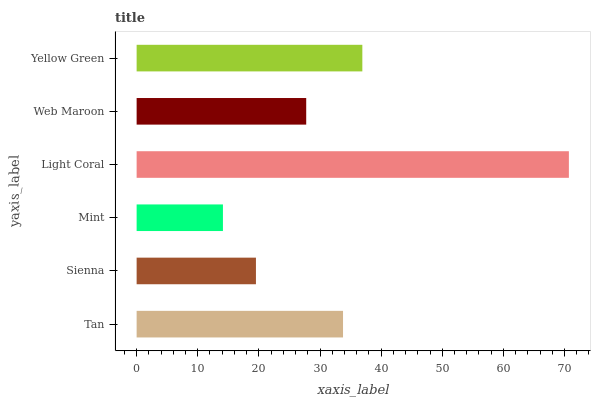Is Mint the minimum?
Answer yes or no. Yes. Is Light Coral the maximum?
Answer yes or no. Yes. Is Sienna the minimum?
Answer yes or no. No. Is Sienna the maximum?
Answer yes or no. No. Is Tan greater than Sienna?
Answer yes or no. Yes. Is Sienna less than Tan?
Answer yes or no. Yes. Is Sienna greater than Tan?
Answer yes or no. No. Is Tan less than Sienna?
Answer yes or no. No. Is Tan the high median?
Answer yes or no. Yes. Is Web Maroon the low median?
Answer yes or no. Yes. Is Sienna the high median?
Answer yes or no. No. Is Sienna the low median?
Answer yes or no. No. 